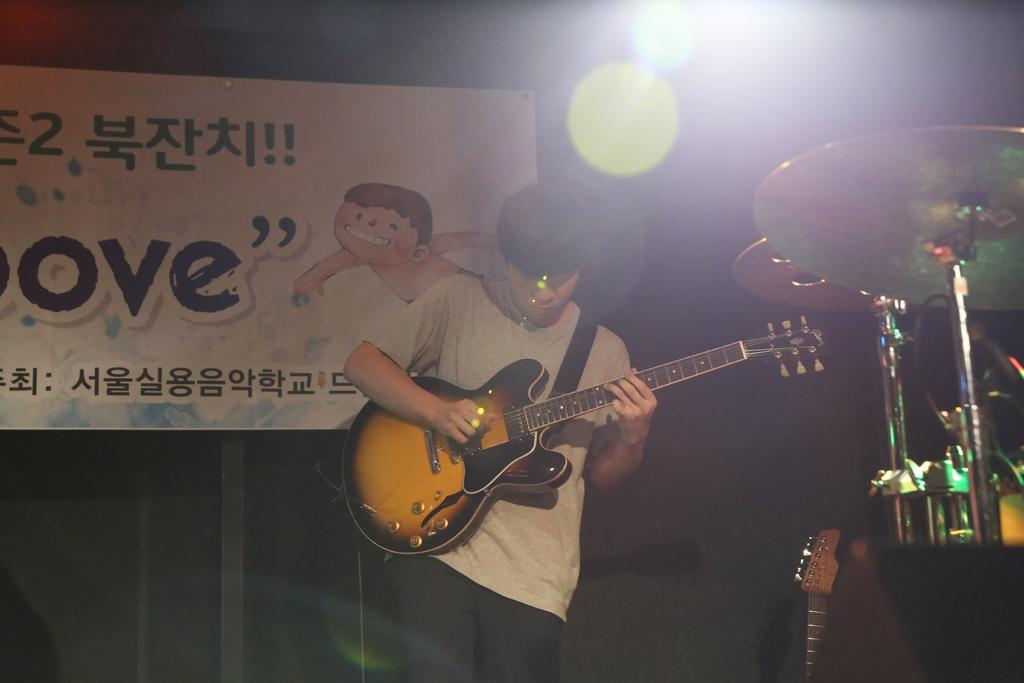What is the man in the image doing? The man is playing a guitar in the image. Are there any other musical instruments present in the image? Yes, there are other musical instruments in the image. What can be seen in the background of the image? There is a banner and a light in the background of the image. How many cats are sitting on the tramp in the image? There are no cats or tramp present in the image. 